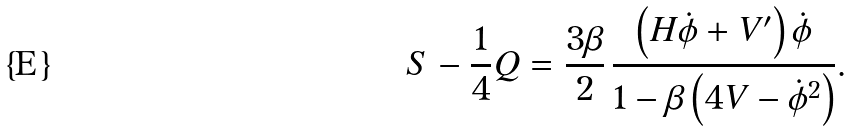<formula> <loc_0><loc_0><loc_500><loc_500>S - \frac { 1 } { 4 } Q = \frac { 3 \beta } { 2 } \, \frac { \left ( H \dot { \phi } + V ^ { \prime } \right ) \dot { \phi } } { 1 - \beta \left ( 4 V - \dot { \phi } ^ { 2 } \right ) } .</formula> 